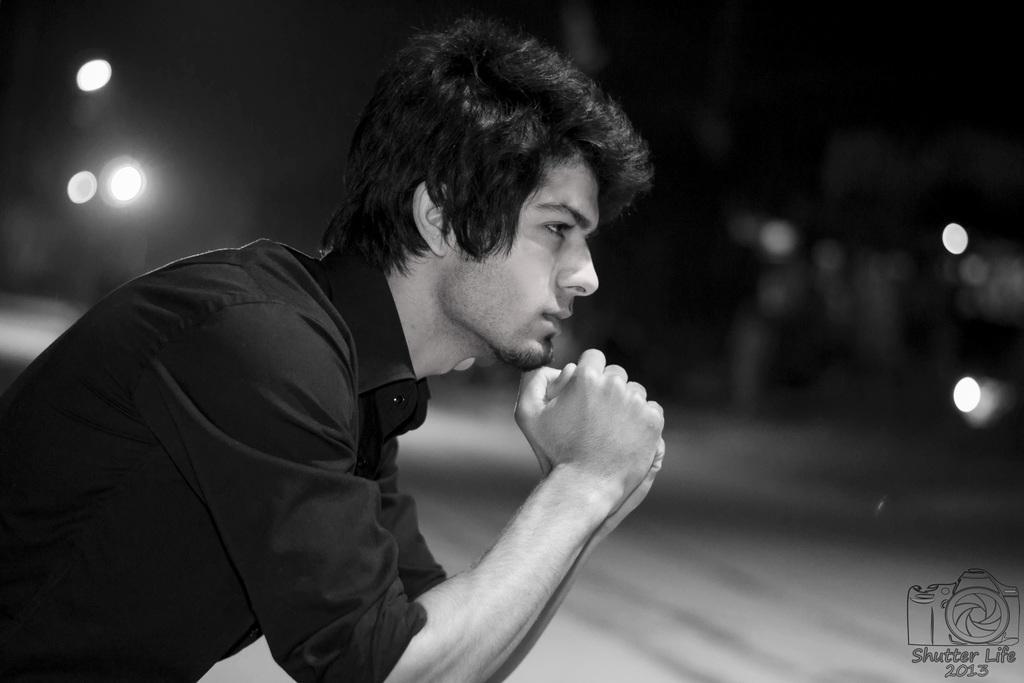Can you describe this image briefly? In this picture I can observe a man wearing a shirt. On the bottom right side I can observe a watermark. The background is blurred. This is a black and white image. 